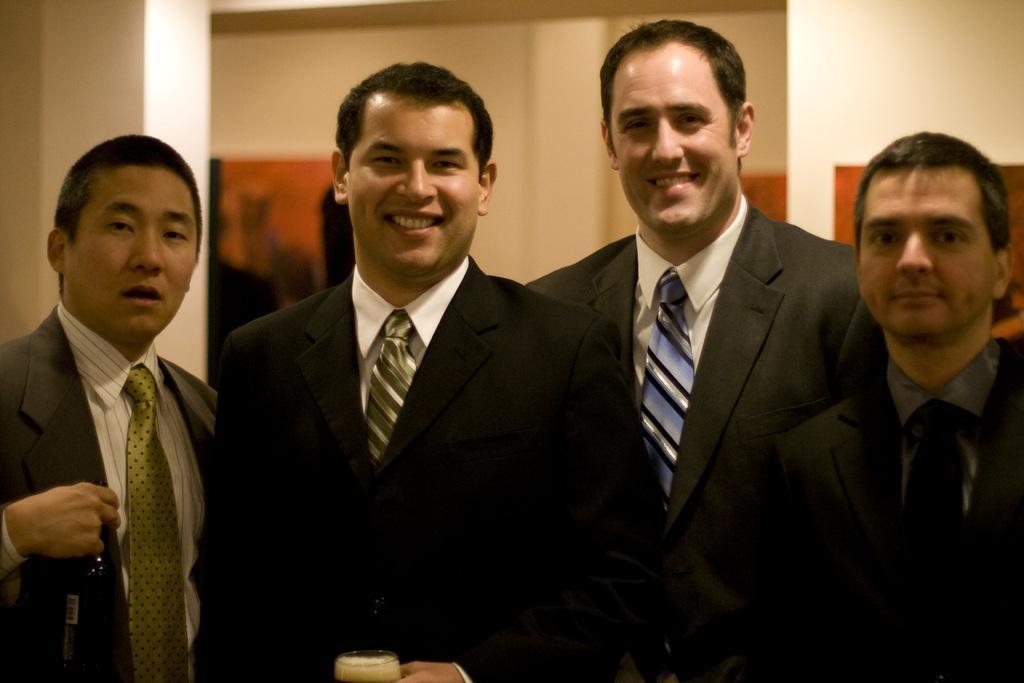Please provide a concise description of this image. In this picture we can see four persons wore blazers, tie and they are smiling. In the background we can see wall, pillars, some paintings, frames and the middle person is holding glass in his hand with full of drink and on left side person is holding bottle in his hand. 